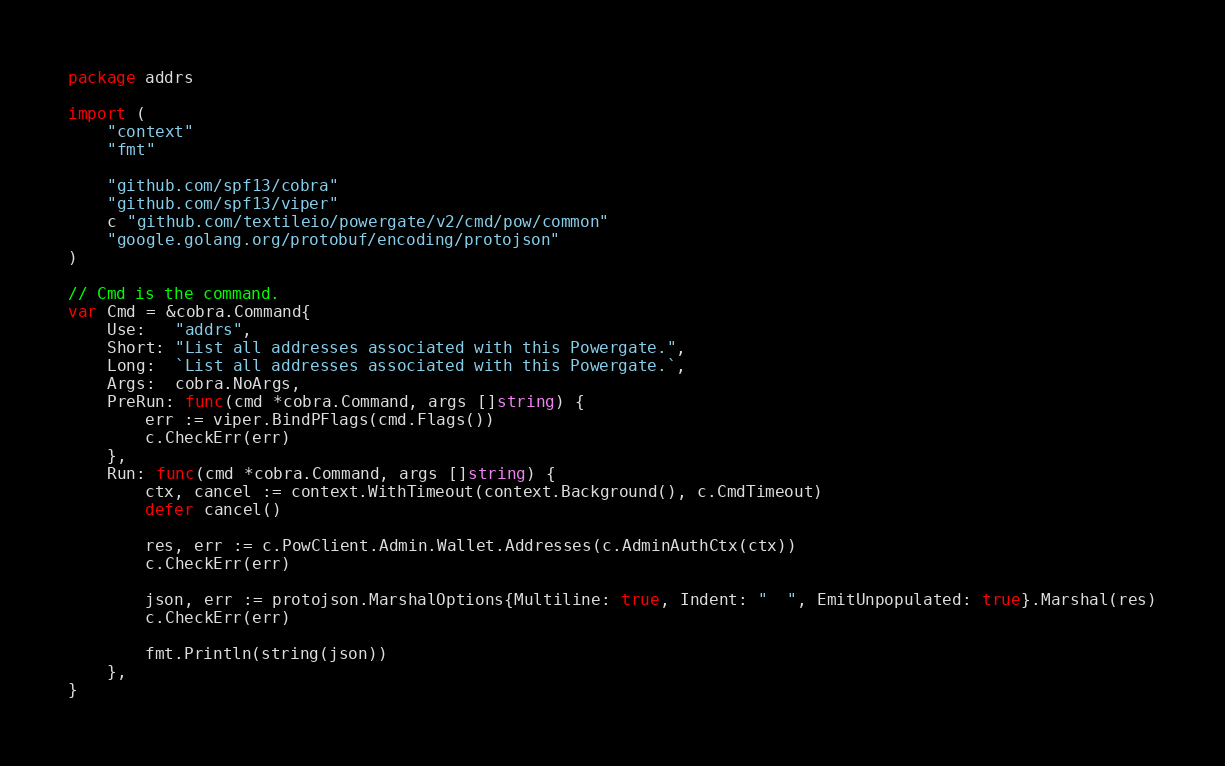<code> <loc_0><loc_0><loc_500><loc_500><_Go_>package addrs

import (
	"context"
	"fmt"

	"github.com/spf13/cobra"
	"github.com/spf13/viper"
	c "github.com/textileio/powergate/v2/cmd/pow/common"
	"google.golang.org/protobuf/encoding/protojson"
)

// Cmd is the command.
var Cmd = &cobra.Command{
	Use:   "addrs",
	Short: "List all addresses associated with this Powergate.",
	Long:  `List all addresses associated with this Powergate.`,
	Args:  cobra.NoArgs,
	PreRun: func(cmd *cobra.Command, args []string) {
		err := viper.BindPFlags(cmd.Flags())
		c.CheckErr(err)
	},
	Run: func(cmd *cobra.Command, args []string) {
		ctx, cancel := context.WithTimeout(context.Background(), c.CmdTimeout)
		defer cancel()

		res, err := c.PowClient.Admin.Wallet.Addresses(c.AdminAuthCtx(ctx))
		c.CheckErr(err)

		json, err := protojson.MarshalOptions{Multiline: true, Indent: "  ", EmitUnpopulated: true}.Marshal(res)
		c.CheckErr(err)

		fmt.Println(string(json))
	},
}
</code> 